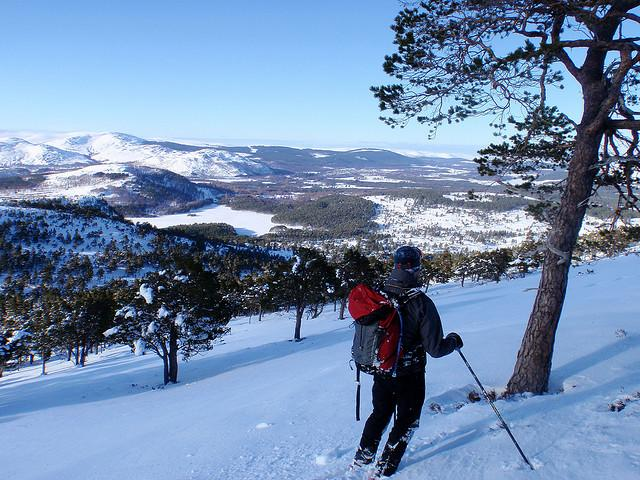What is the man doing in the snow? skiing 